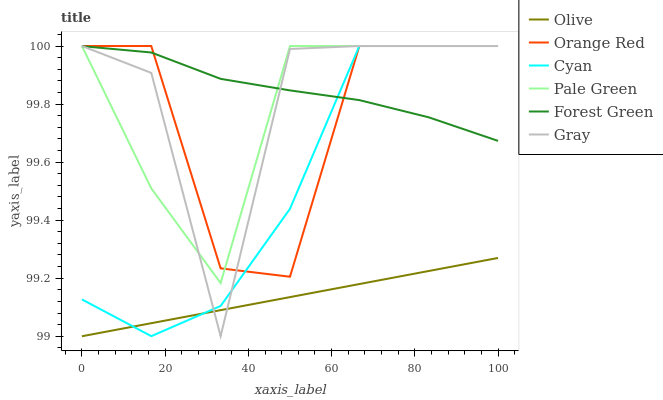Does Olive have the minimum area under the curve?
Answer yes or no. Yes. Does Forest Green have the maximum area under the curve?
Answer yes or no. Yes. Does Pale Green have the minimum area under the curve?
Answer yes or no. No. Does Pale Green have the maximum area under the curve?
Answer yes or no. No. Is Olive the smoothest?
Answer yes or no. Yes. Is Gray the roughest?
Answer yes or no. Yes. Is Forest Green the smoothest?
Answer yes or no. No. Is Forest Green the roughest?
Answer yes or no. No. Does Olive have the lowest value?
Answer yes or no. Yes. Does Pale Green have the lowest value?
Answer yes or no. No. Does Orange Red have the highest value?
Answer yes or no. Yes. Does Forest Green have the highest value?
Answer yes or no. No. Is Olive less than Forest Green?
Answer yes or no. Yes. Is Forest Green greater than Olive?
Answer yes or no. Yes. Does Forest Green intersect Cyan?
Answer yes or no. Yes. Is Forest Green less than Cyan?
Answer yes or no. No. Is Forest Green greater than Cyan?
Answer yes or no. No. Does Olive intersect Forest Green?
Answer yes or no. No. 